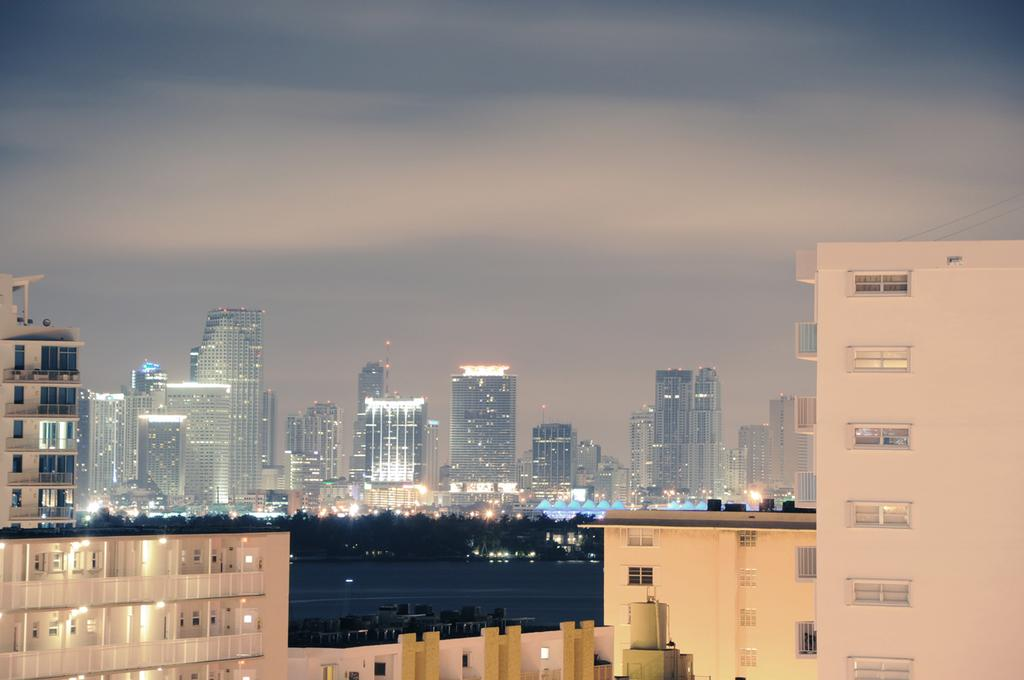What type of structures can be seen in the image? There are buildings in the image. What natural element is visible in the image? There is water visible in the image. What type of vegetation is present in the image? There are trees in the image. What part of the natural environment is visible in the image? The sky is visible in the image. How would you describe the lighting in the image? The image appears to be slightly dark. What type of coil is being used to cause a rifle to fire in the image? There is no coil, cause, or rifle present in the image. 